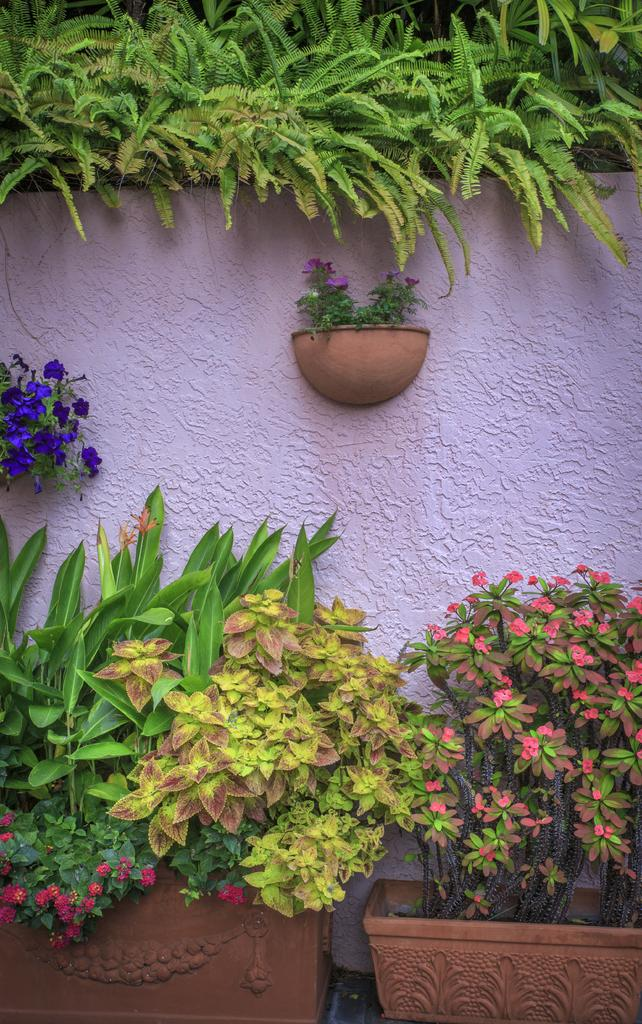What types of living organisms can be seen at the bottom of the picture? Plants and flowers can be seen at the bottom of the picture. What objects are present at the bottom of the picture? Flower pots are present at the bottom of the picture. What can be seen in the center of the picture? There are plants, flowers, and a wall in the center of the picture. What types of living organisms can be seen at the top of the picture? Plants can be seen at the top of the picture. What type of sock is hanging on the wall in the image? There is no sock present in the image; it features plants, flowers, and a wall. What is the maid doing in the image? There is no maid present in the image. 